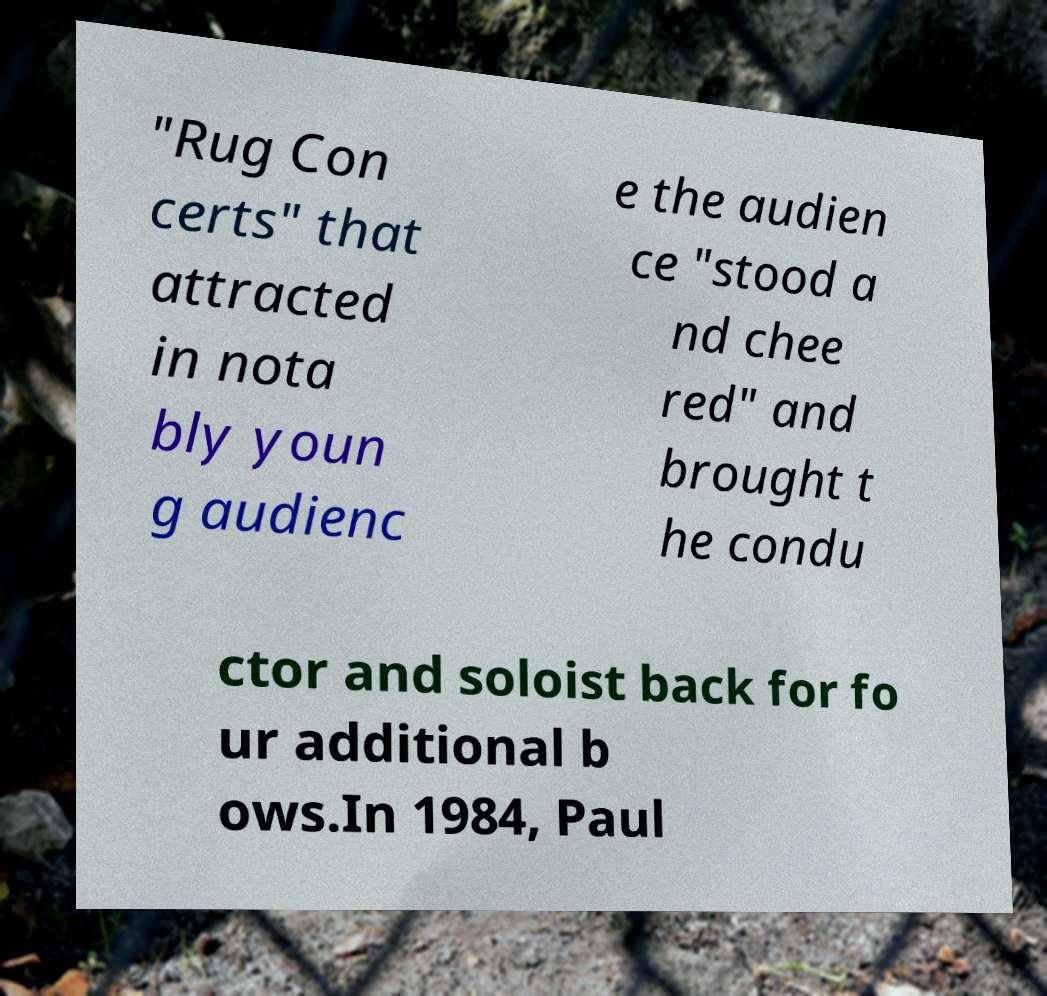Please identify and transcribe the text found in this image. "Rug Con certs" that attracted in nota bly youn g audienc e the audien ce "stood a nd chee red" and brought t he condu ctor and soloist back for fo ur additional b ows.In 1984, Paul 